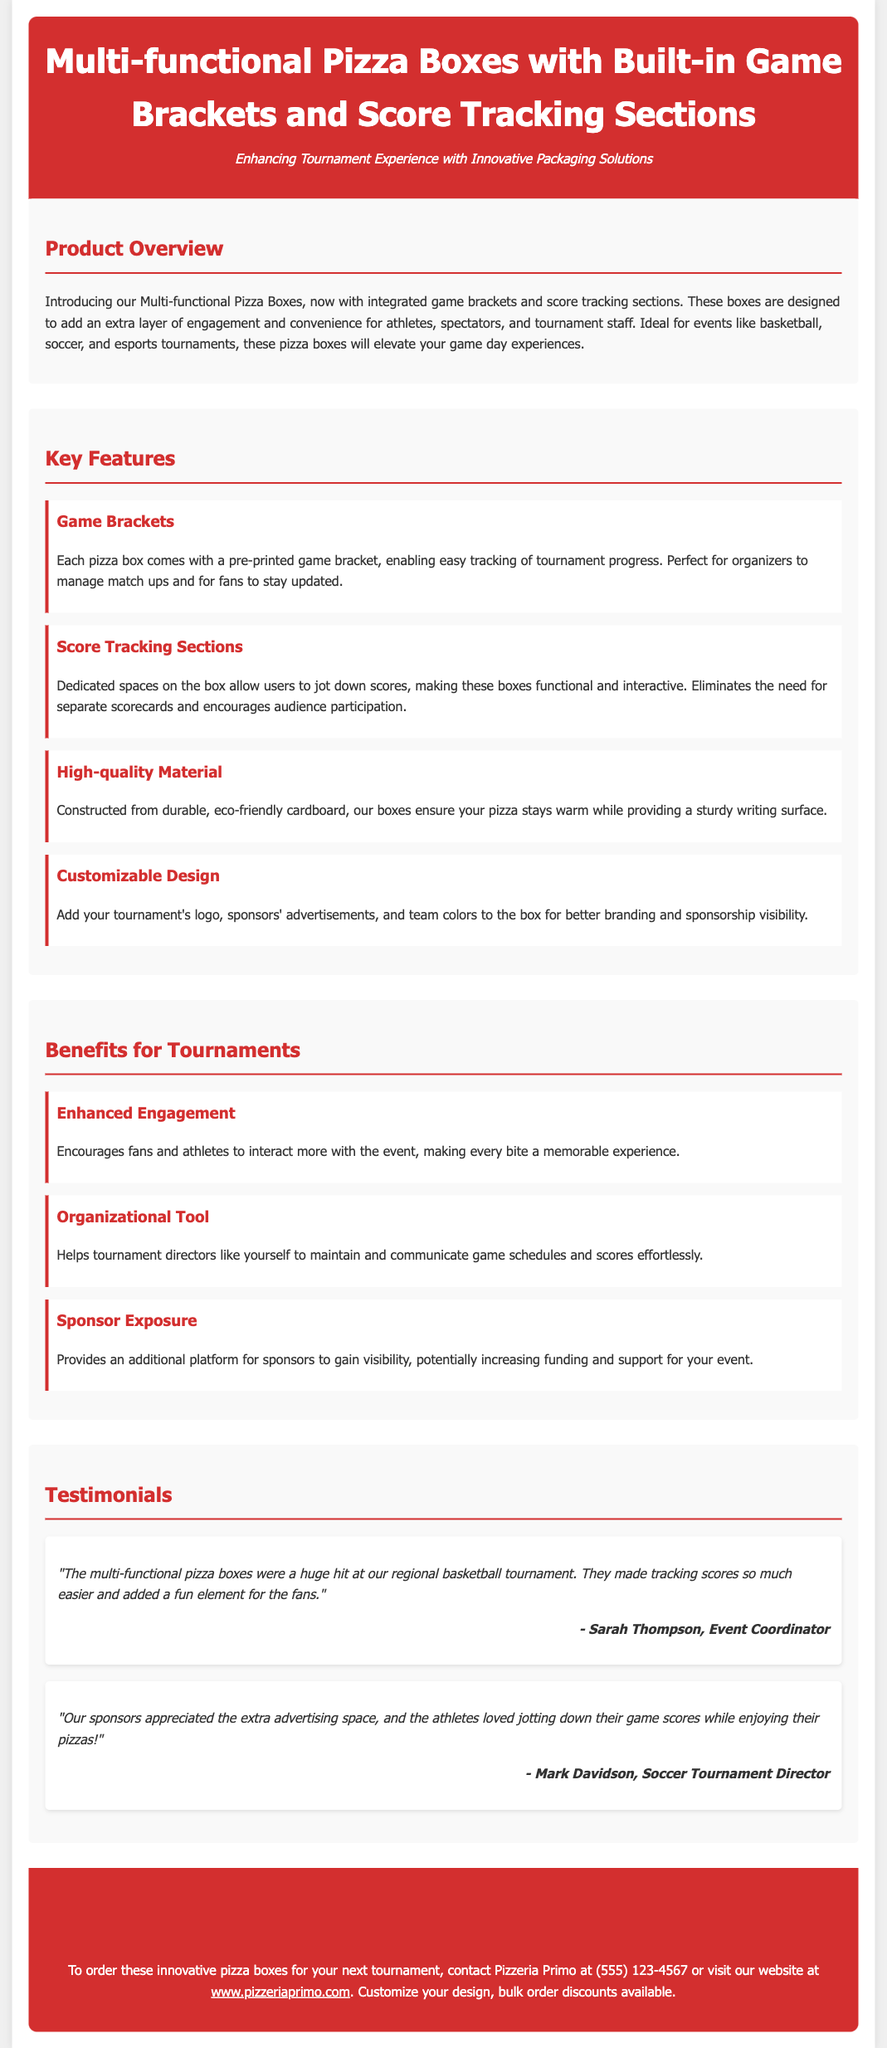What are the pizza boxes designed for? The pizza boxes are designed to add an extra layer of engagement and convenience for athletes, spectators, and tournament staff.
Answer: Engagement and convenience What material are the pizza boxes made from? The pizza boxes are constructed from durable, eco-friendly cardboard.
Answer: Eco-friendly cardboard What is one feature of the pizza boxes? One feature is the game brackets that enable easy tracking of tournament progress.
Answer: Game brackets How should organizers contact Pizzeria Primo? Organizers should contact Pizzeria Primo at (555) 123-4567 or visit their website.
Answer: (555) 123-4567 What is a benefit for tournaments mentioned in the document? A benefit mentioned is enhanced engagement for fans and athletes.
Answer: Enhanced engagement What additional platform do the pizza boxes provide? The pizza boxes provide an additional platform for sponsors to gain visibility.
Answer: Sponsor visibility How do the pizza boxes help tournament directors? They help tournament directors maintain and communicate game schedules and scores effortlessly.
Answer: Organizational tool What kind of tournament is associated with the testimonials? The testimonials mention a regional basketball tournament.
Answer: Basketball tournament 